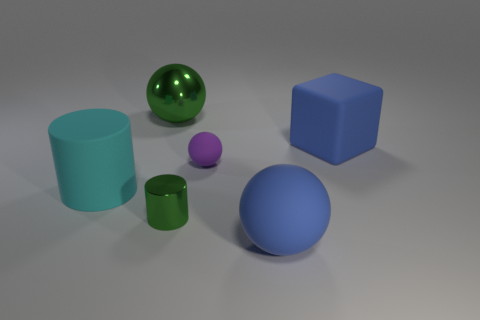Are there any other things of the same color as the tiny rubber thing?
Provide a succinct answer. No. What number of tiny purple cubes are there?
Give a very brief answer. 0. What is the material of the large sphere left of the big sphere that is on the right side of the tiny purple object?
Keep it short and to the point. Metal. The shiny thing behind the object on the right side of the big matte thing in front of the big cyan matte cylinder is what color?
Provide a succinct answer. Green. Does the tiny matte ball have the same color as the big cylinder?
Your answer should be compact. No. What number of cylinders have the same size as the purple object?
Give a very brief answer. 1. Is the number of large spheres that are in front of the blue cube greater than the number of matte blocks that are to the left of the purple matte thing?
Make the answer very short. Yes. There is a big object that is behind the large blue rubber thing that is behind the big cyan thing; what is its color?
Your response must be concise. Green. Do the small purple thing and the blue cube have the same material?
Give a very brief answer. Yes. Are there any blue things of the same shape as the tiny purple thing?
Your answer should be compact. Yes. 